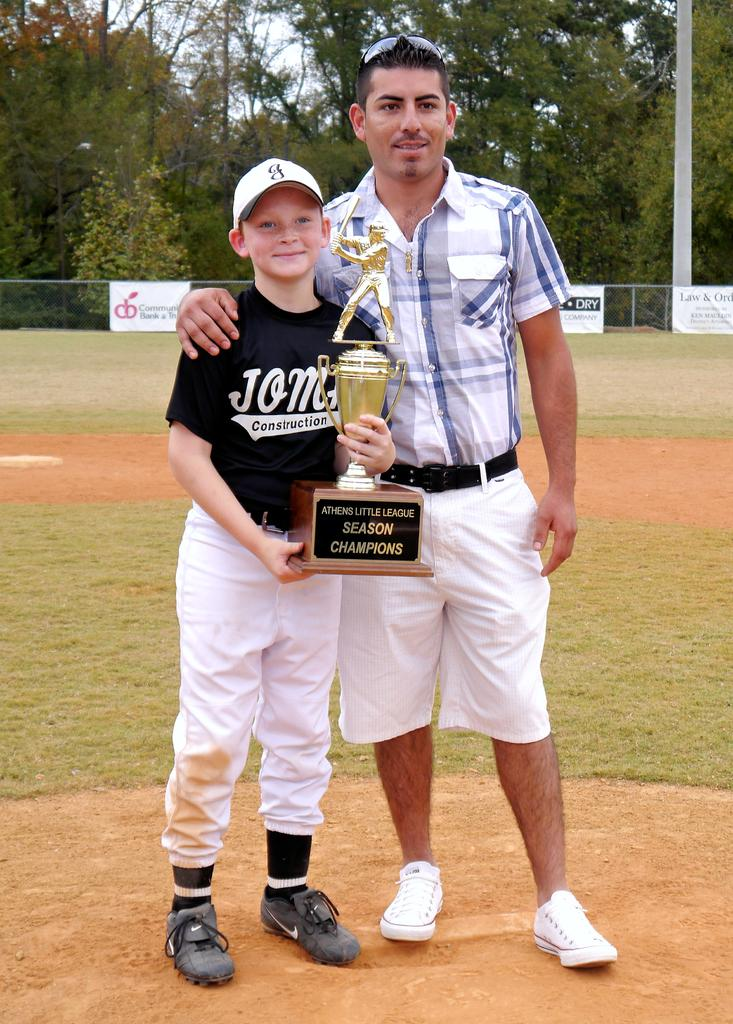<image>
Summarize the visual content of the image. A man is standing with a young baseball player holding a trophy that says Athens Little League Season Champions. 